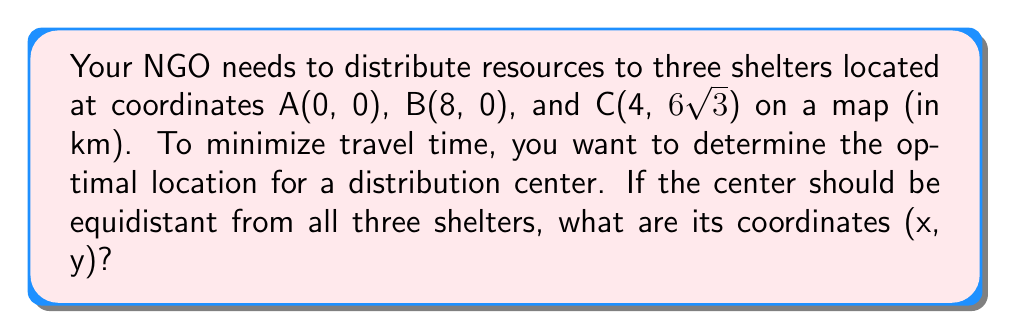Can you answer this question? 1) The distribution center should be at the circumcenter of triangle ABC, as it's equidistant from all vertices.

2) Given the coordinates, we can see that triangle ABC is equilateral:
   - AB = 8 km
   - BC = AC = $\sqrt{4^2 + (6\sqrt{3})^2} = \sqrt{16 + 108} = \sqrt{124} = 2\sqrt{31} = 8$ km

3) In an equilateral triangle, the circumcenter is located at the intersection of the medians, which is 2/3 of the way from any vertex to the midpoint of the opposite side.

4) Let's choose vertex A as our reference point. The midpoint of BC is (6, 3√3).

5) The x-coordinate of the distribution center:
   $x = 0 + \frac{2}{3}(6 - 0) = 4$ km

6) The y-coordinate of the distribution center:
   $y = 0 + \frac{2}{3}(3\sqrt{3} - 0) = 2\sqrt{3}$ km

Therefore, the coordinates of the optimal distribution center are (4, 2√3) km.
Answer: (4, 2√3) km 